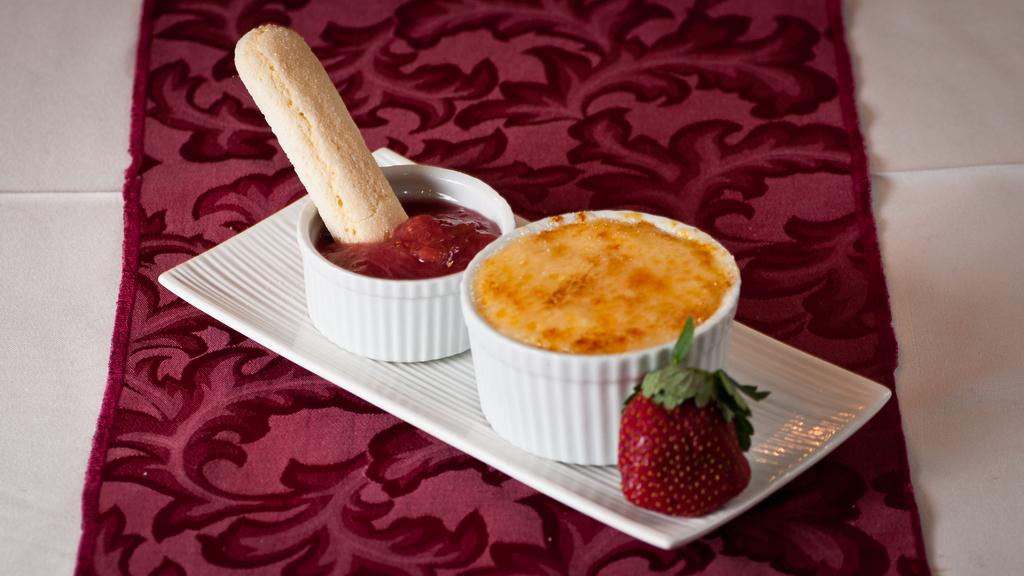What type of flooring is visible in the image? There are white color tiles in the image. What type of floor covering is present in the image? There is a mat in the image. What is used to hold items in the image? There is a tray in the image. What type of containers are present in the image? There are bowls in the image. What is inside the bowls? There are dishes in the bowls. What type of fruit can be seen in the image? There is strawberry in the image. How does the earthquake affect the arrangement of the bowls in the image? There is no earthquake present in the image, so the arrangement of the bowls is not affected by one. 